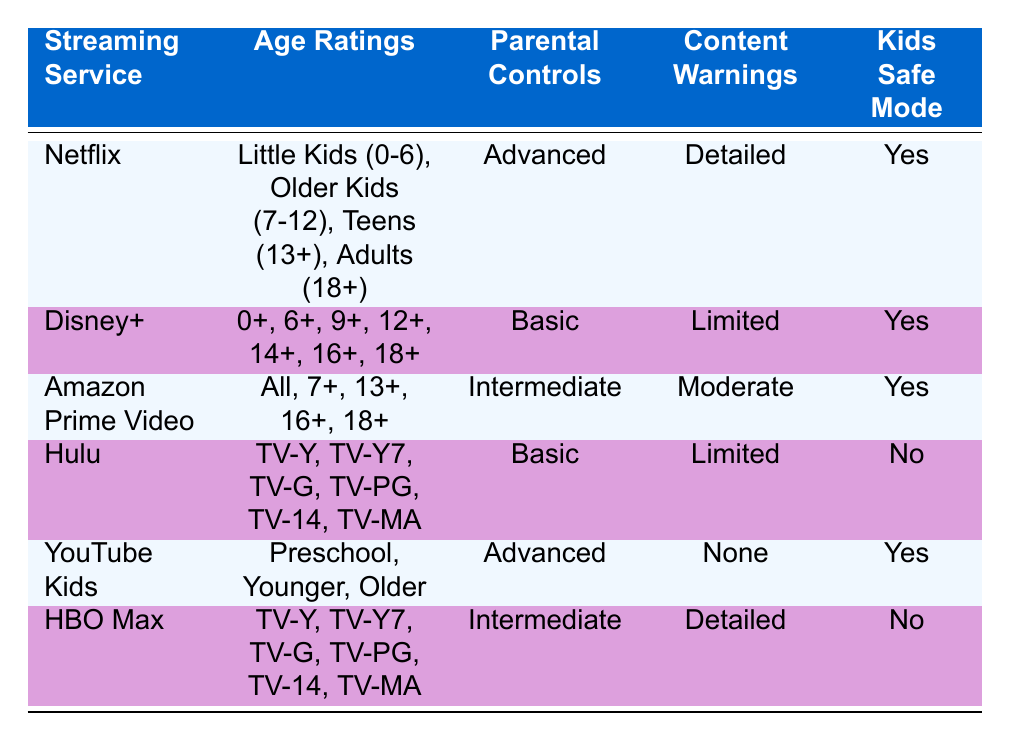What are the age ratings for Disney+? The age ratings for Disney+ are listed in the table as 0+, 6+, 9+, 12+, 14+, 16+, and 18+.
Answer: 0+, 6+, 9+, 12+, 14+, 16+, 18+ Which streaming service has detailed content warnings? By examining the content warnings for each service in the table, Netflix and HBO Max are the only ones with detailed content warnings listed.
Answer: Netflix and HBO Max Does Hulu offer a kids safe mode? The table indicates that Hulu has 'No' under the Kids Safe Mode column.
Answer: No How many streaming services offer advanced parental controls? The table shows that Netflix and YouTube Kids both have advanced parental controls. Thus, there are 2 services offering advanced controls.
Answer: 2 Which streaming service has the least number of age ratings? From the table, YouTube Kids lists three age ratings: Preschool, Younger, and Older. This is fewer than any other service.
Answer: YouTube Kids What is the content warning level of Amazon Prime Video? Looking at the content warnings column for Amazon Prime Video, it states 'Moderate'. So the content warning level is moderate.
Answer: Moderate Which streaming services have kids safe modes enabled? The table shows that Netflix, Disney+, Amazon Prime Video, and YouTube Kids have 'Yes' under the Kids Safe Mode column.
Answer: Netflix, Disney+, Amazon Prime Video, YouTube Kids Is there any service that has both advanced parental controls and kids safe mode? Both Netflix and YouTube Kids have 'Yes' for kids safe mode and 'Advanced' for parental controls as per the table.
Answer: Yes, Netflix and YouTube Kids How does the number of age ratings for Hulu compare to that of Amazon Prime Video? Hulu has 6 age ratings listed, while Amazon Prime Video has 5 age ratings. Therefore, Hulu has more ratings than Amazon Prime Video.
Answer: Hulu has more age ratings than Amazon Prime Video 